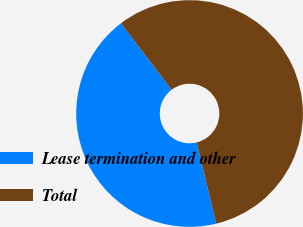<chart> <loc_0><loc_0><loc_500><loc_500><pie_chart><fcel>Lease termination and other<fcel>Total<nl><fcel>43.45%<fcel>56.55%<nl></chart> 